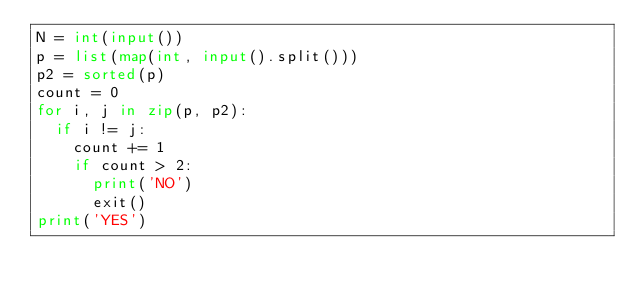<code> <loc_0><loc_0><loc_500><loc_500><_Python_>N = int(input())
p = list(map(int, input().split()))
p2 = sorted(p)
count = 0
for i, j in zip(p, p2):
  if i != j:
    count += 1
    if count > 2:
      print('NO')
      exit()
print('YES')</code> 